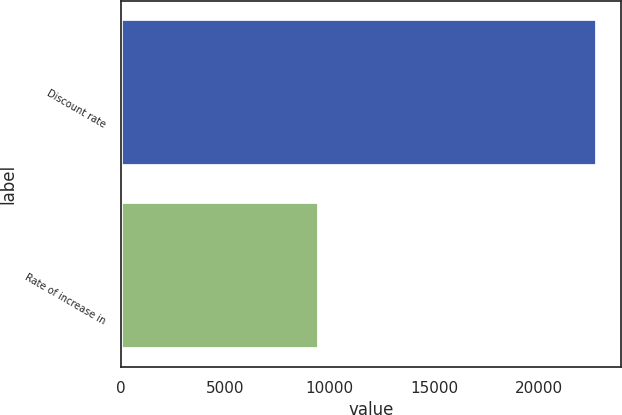Convert chart to OTSL. <chart><loc_0><loc_0><loc_500><loc_500><bar_chart><fcel>Discount rate<fcel>Rate of increase in<nl><fcel>22778<fcel>9499<nl></chart> 